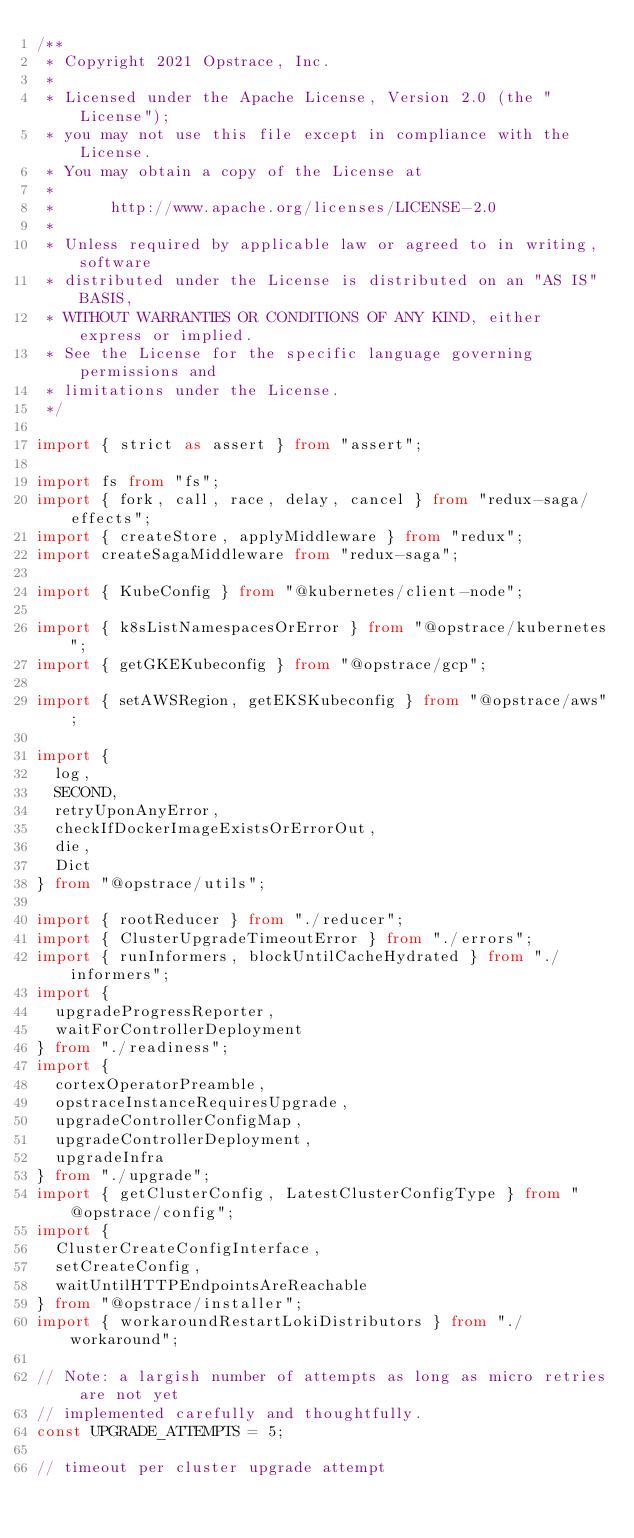Convert code to text. <code><loc_0><loc_0><loc_500><loc_500><_TypeScript_>/**
 * Copyright 2021 Opstrace, Inc.
 *
 * Licensed under the Apache License, Version 2.0 (the "License");
 * you may not use this file except in compliance with the License.
 * You may obtain a copy of the License at
 *
 *      http://www.apache.org/licenses/LICENSE-2.0
 *
 * Unless required by applicable law or agreed to in writing, software
 * distributed under the License is distributed on an "AS IS" BASIS,
 * WITHOUT WARRANTIES OR CONDITIONS OF ANY KIND, either express or implied.
 * See the License for the specific language governing permissions and
 * limitations under the License.
 */

import { strict as assert } from "assert";

import fs from "fs";
import { fork, call, race, delay, cancel } from "redux-saga/effects";
import { createStore, applyMiddleware } from "redux";
import createSagaMiddleware from "redux-saga";

import { KubeConfig } from "@kubernetes/client-node";

import { k8sListNamespacesOrError } from "@opstrace/kubernetes";
import { getGKEKubeconfig } from "@opstrace/gcp";

import { setAWSRegion, getEKSKubeconfig } from "@opstrace/aws";

import {
  log,
  SECOND,
  retryUponAnyError,
  checkIfDockerImageExistsOrErrorOut,
  die,
  Dict
} from "@opstrace/utils";

import { rootReducer } from "./reducer";
import { ClusterUpgradeTimeoutError } from "./errors";
import { runInformers, blockUntilCacheHydrated } from "./informers";
import {
  upgradeProgressReporter,
  waitForControllerDeployment
} from "./readiness";
import {
  cortexOperatorPreamble,
  opstraceInstanceRequiresUpgrade,
  upgradeControllerConfigMap,
  upgradeControllerDeployment,
  upgradeInfra
} from "./upgrade";
import { getClusterConfig, LatestClusterConfigType } from "@opstrace/config";
import {
  ClusterCreateConfigInterface,
  setCreateConfig,
  waitUntilHTTPEndpointsAreReachable
} from "@opstrace/installer";
import { workaroundRestartLokiDistributors } from "./workaround";

// Note: a largish number of attempts as long as micro retries are not yet
// implemented carefully and thoughtfully.
const UPGRADE_ATTEMPTS = 5;

// timeout per cluster upgrade attempt</code> 